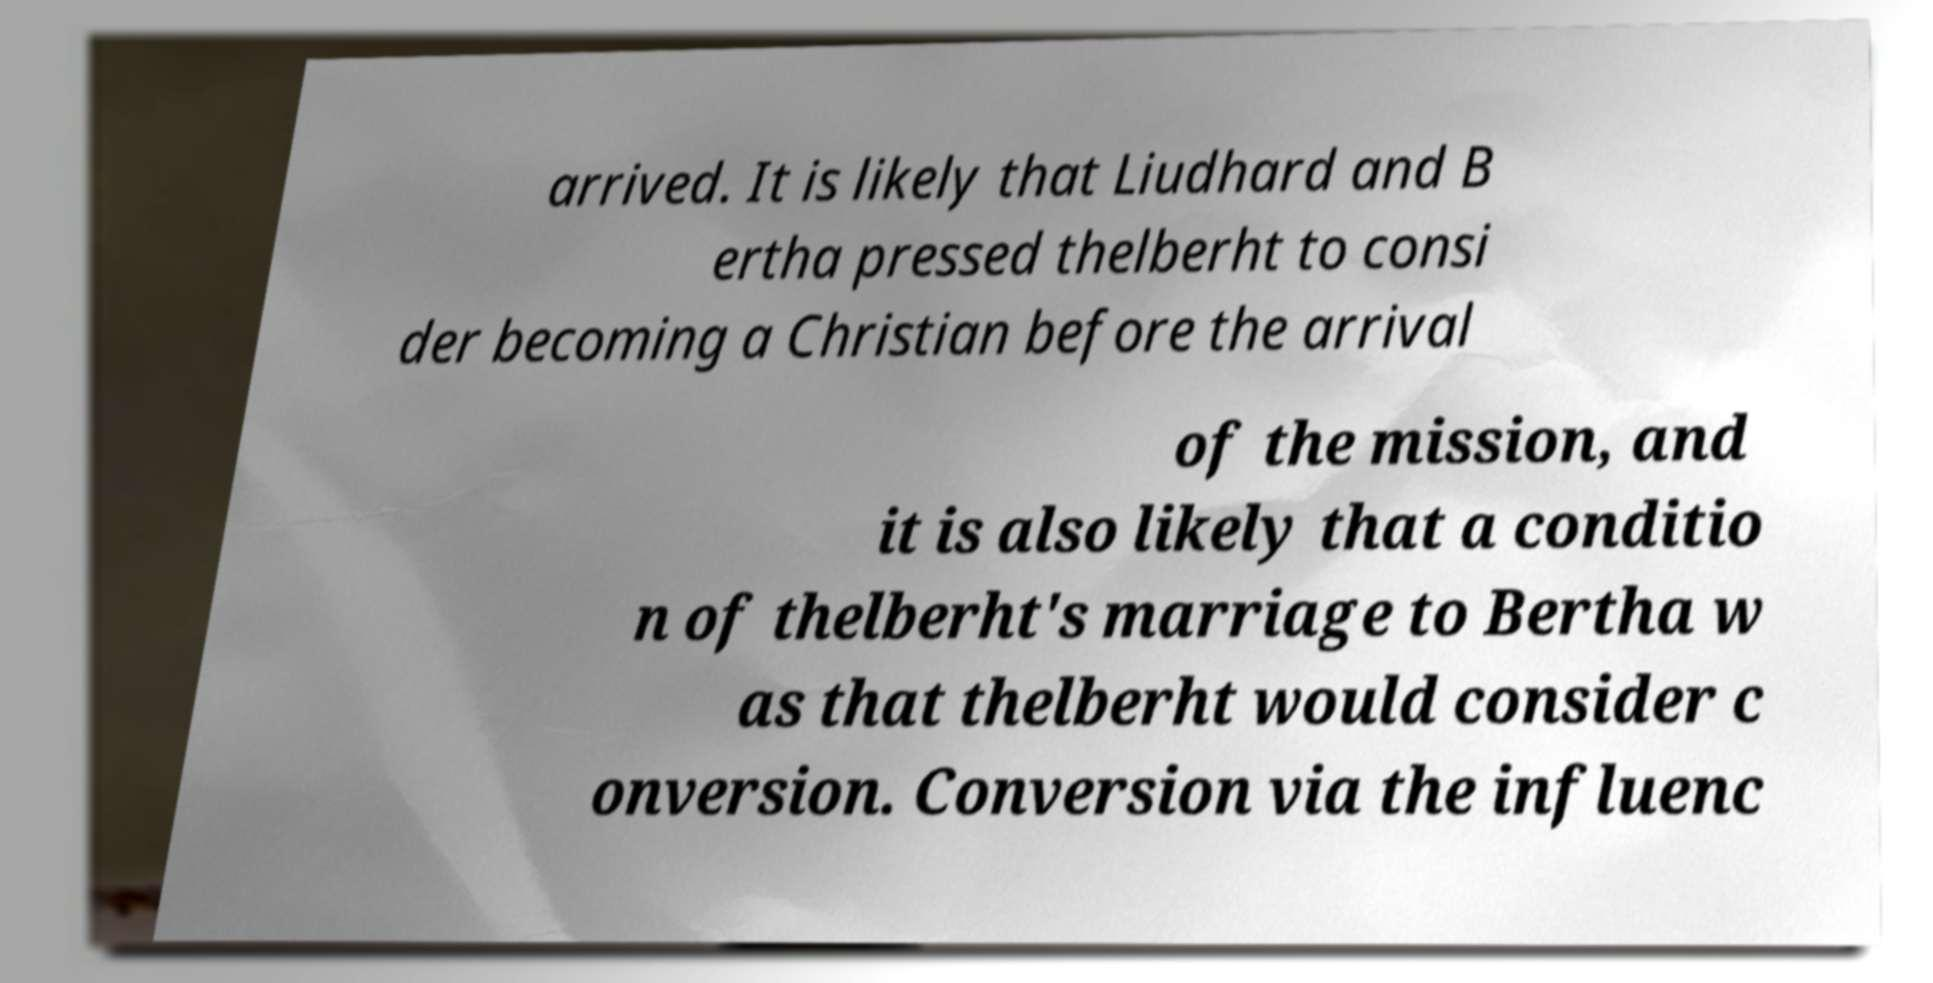Please read and relay the text visible in this image. What does it say? arrived. It is likely that Liudhard and B ertha pressed thelberht to consi der becoming a Christian before the arrival of the mission, and it is also likely that a conditio n of thelberht's marriage to Bertha w as that thelberht would consider c onversion. Conversion via the influenc 